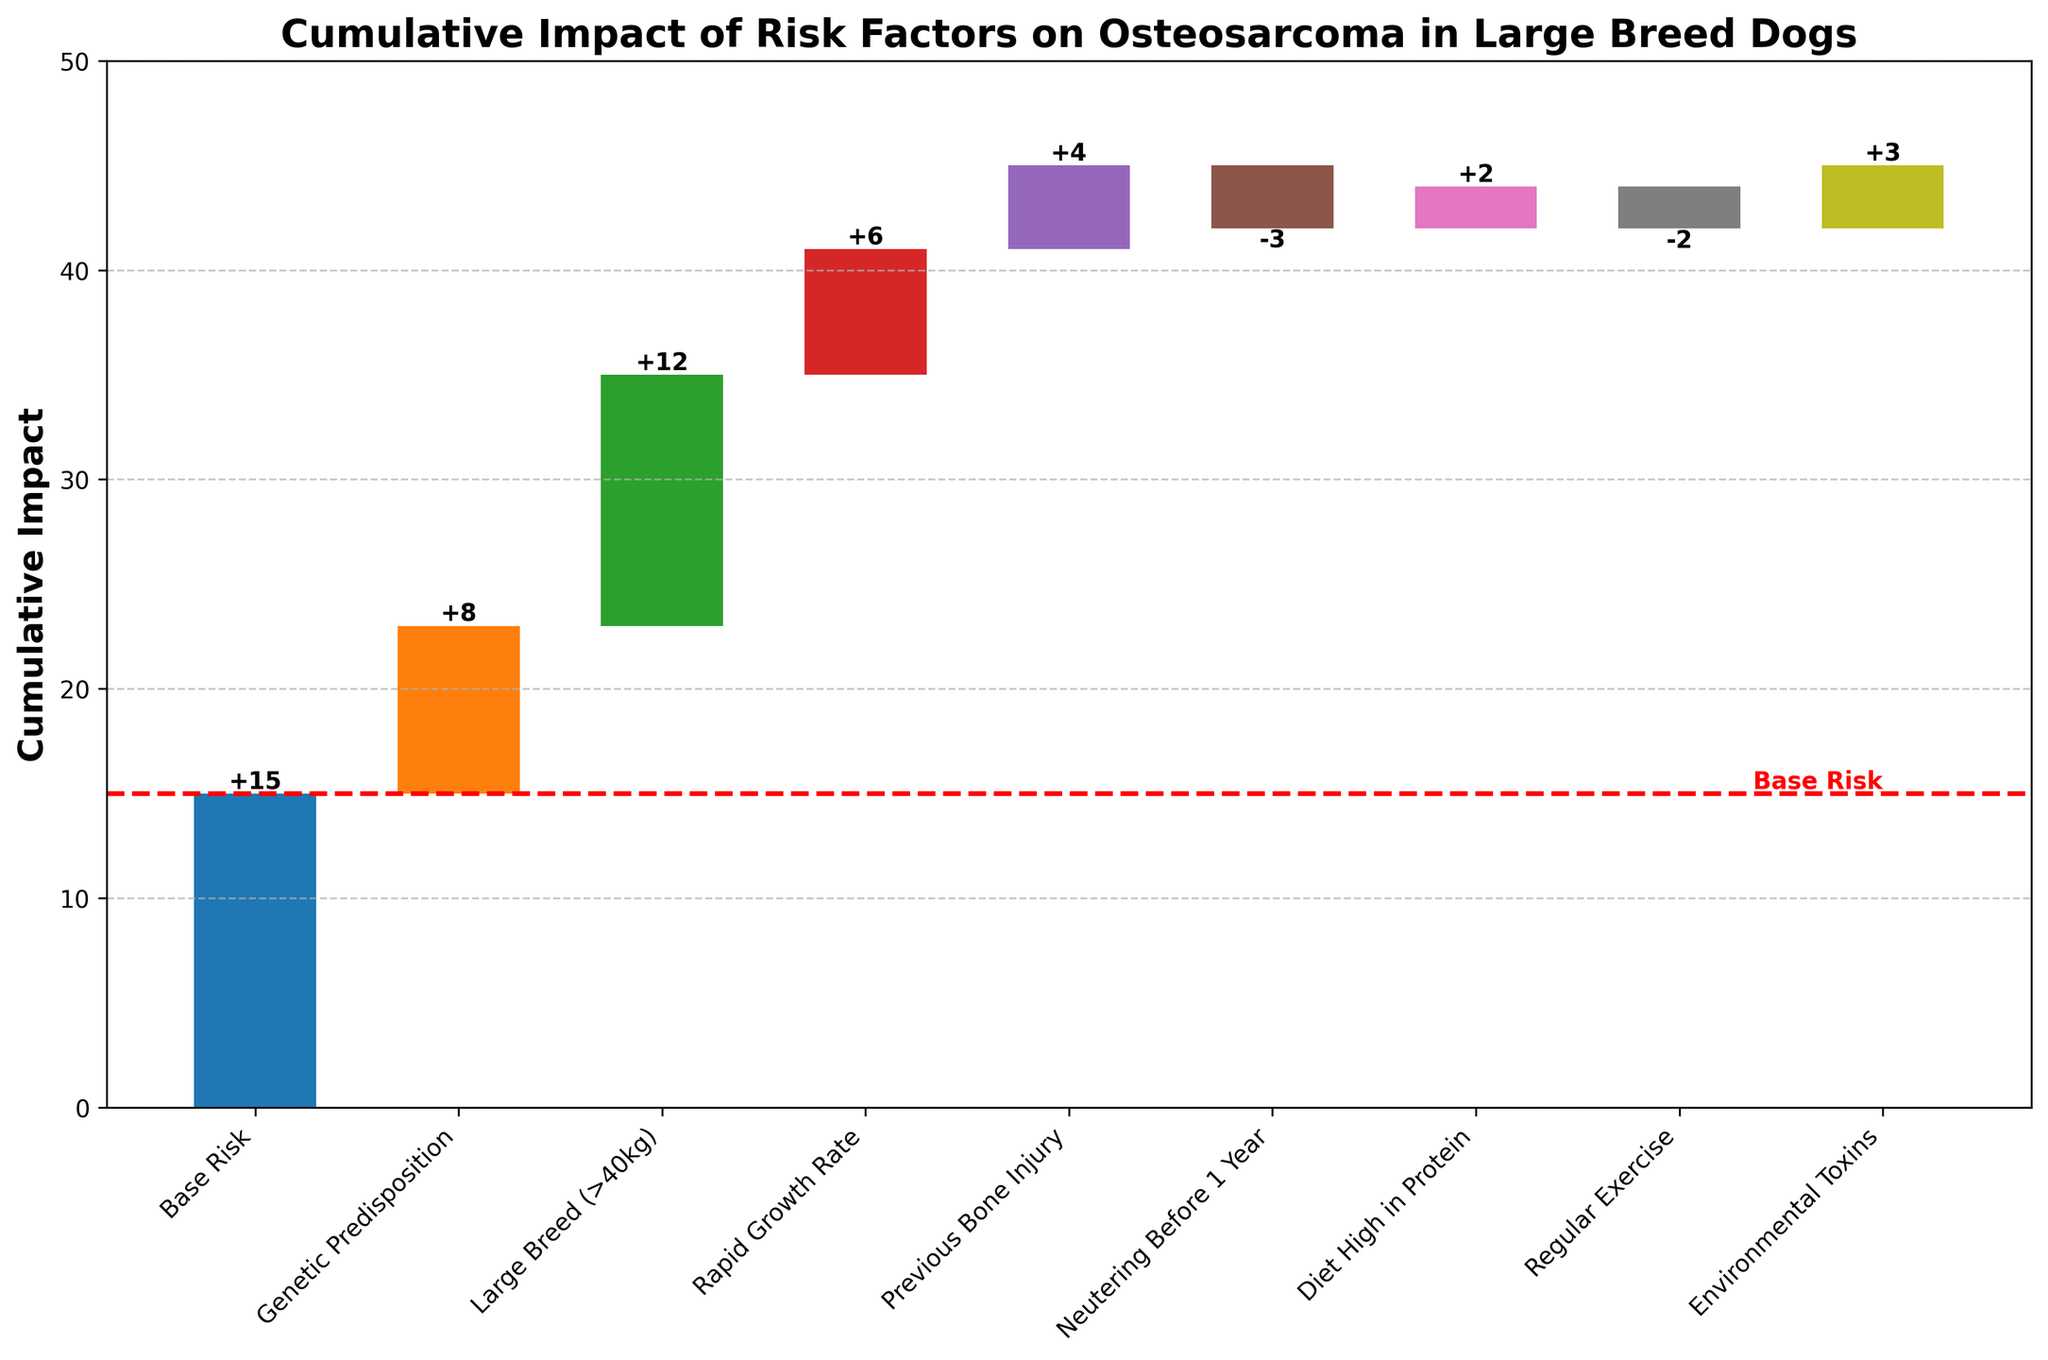What is the title of the chart? The title of the chart is displayed prominently at the top of the figure.
Answer: Cumulative Impact of Risk Factors on Osteosarcoma in Large Breed Dogs How many risk factors are listed in the chart? Count the number of categories presented along the x-axis, excluding the base risk and total risk.
Answer: 8 Which single risk factor has the greatest positive impact on osteosarcoma risk? Identify the risk factor bar with the highest value in the positive direction.
Answer: Large Breed (>40kg) What is the impact of neutering before 1 year on osteosarcoma risk? Look for the bar labeled 'Neutering Before 1 Year' and check the value associated with it.
Answer: -3 What's the cumulative impact after considering genetic predisposition and large breed? The base risk is 15, with subsequent added positive impacts of 8 (genetic predisposition) and 12 (large breed), so 15 + 8 + 12 = 35.
Answer: 35 What is the final cumulative risk value depicted in the chart? The final cumulative risk value is the last value at the end of the sequence of bars, representing the total sum of all contributions.
Answer: 45 How does the impact of rapid growth rate compare to regular exercise? Compare the heights of the bars labeled 'Rapid Growth Rate' and 'Regular Exercise'. Rapid Growth Rate has a positive impact of 6, while Regular Exercise has a negative impact of 2.
Answer: Higher What cumulative impact is observed after accounting for all positively contributing factors only? Sum the impacts of all positive factors: 15 (base) + 8 (genetic) + 12 (large breed) + 6 (rapid growth) + 4 (bone injury) + 2 (high protein) + 3 (environmental toxins) = 50.
Answer: 50 What is the combined impact of diet high in protein and regular exercise on osteosarcoma risk? Find the values of both factors, then add them. Diet High in Protein is +2 and Regular Exercise is -2, so +2 - 2 = 0.
Answer: 0 